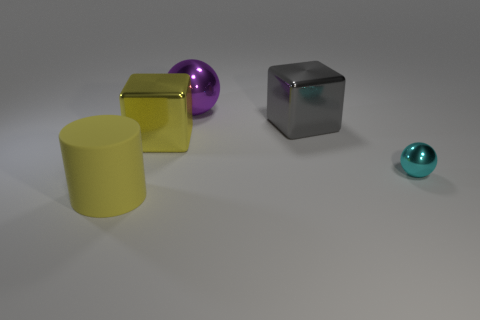Is there anything else that has the same size as the cyan shiny thing?
Give a very brief answer. No. Does the large shiny cube to the right of the large purple sphere have the same color as the large cube that is in front of the large gray metallic block?
Give a very brief answer. No. Is there any other thing that is made of the same material as the purple sphere?
Your answer should be compact. Yes. What size is the purple thing that is the same shape as the cyan metallic object?
Your answer should be very brief. Large. Is the number of large shiny things on the left side of the large purple sphere greater than the number of brown shiny things?
Provide a succinct answer. Yes. Does the yellow object that is behind the large yellow matte cylinder have the same material as the big purple object?
Your response must be concise. Yes. There is a cube that is to the right of the big metal object that is behind the big cube to the right of the large purple shiny sphere; what is its size?
Your response must be concise. Large. There is a gray cube that is the same material as the purple thing; what size is it?
Offer a terse response. Large. The large object that is both to the left of the purple object and behind the tiny ball is what color?
Offer a terse response. Yellow. There is a large yellow thing right of the large yellow rubber cylinder; is it the same shape as the object behind the large gray metallic object?
Make the answer very short. No. 